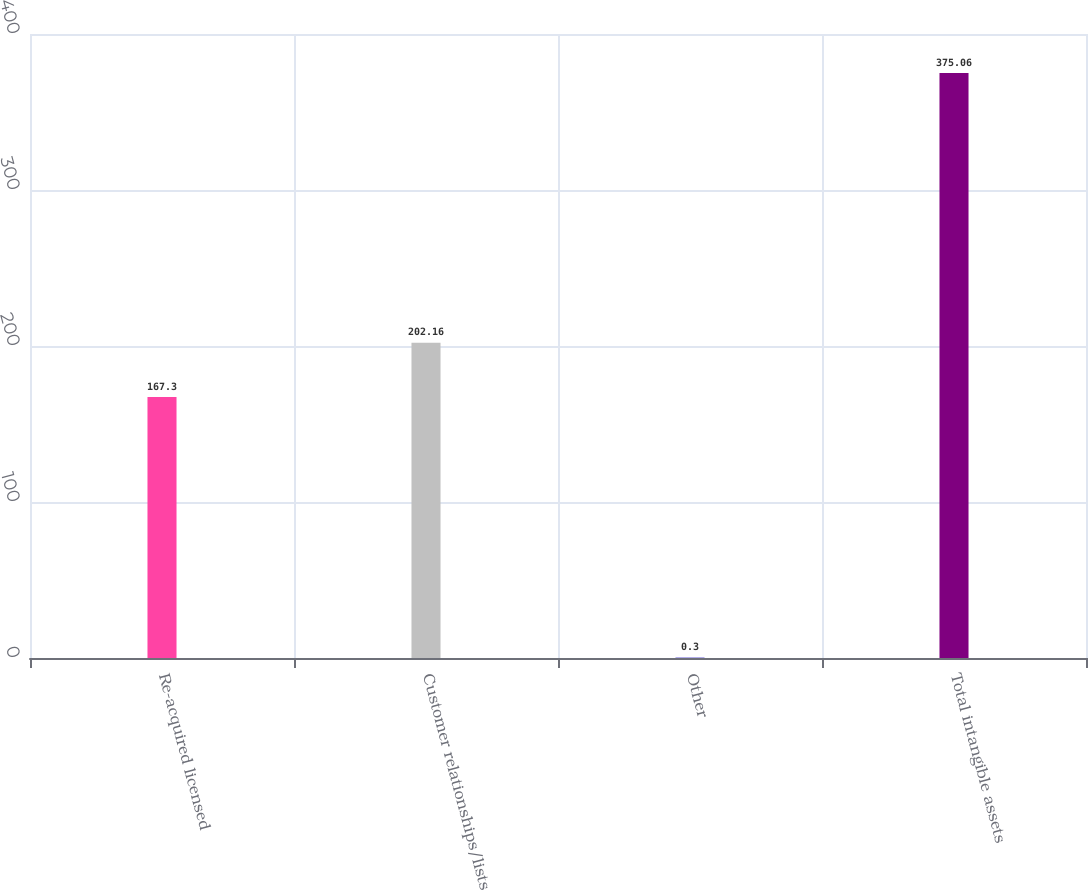Convert chart to OTSL. <chart><loc_0><loc_0><loc_500><loc_500><bar_chart><fcel>Re-acquired licensed<fcel>Customer relationships/lists<fcel>Other<fcel>Total intangible assets<nl><fcel>167.3<fcel>202.16<fcel>0.3<fcel>375.06<nl></chart> 